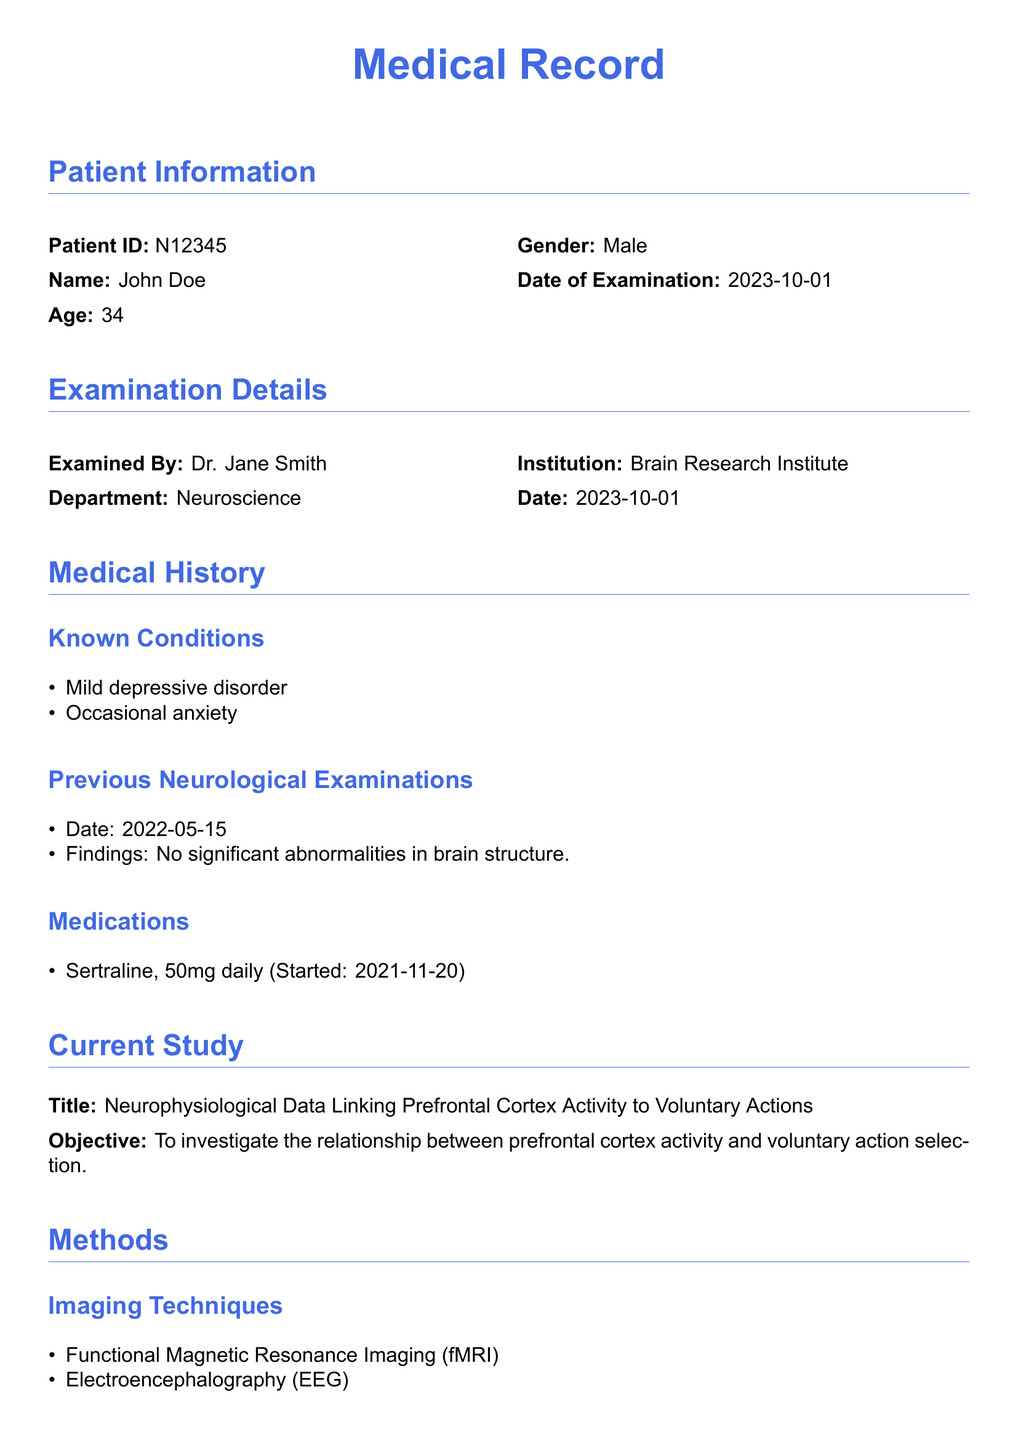What is the patient's age? The patient's age is directly mentioned in the document under Patient Information.
Answer: 34 Who examined the patient? The name of the person who examined the patient is listed in the Examination Details section.
Answer: Dr. Jane Smith What imaging techniques were used in the study? The document lists the imaging techniques used under the Methods section.
Answer: Functional Magnetic Resonance Imaging (fMRI), Electroencephalography (EEG) Which brain regions showed increased activity during voluntary action tasks? The document specifies the implicated brain regions under Prefrontal Cortex Activity in the Findings section.
Answer: Dorsolateral Prefrontal Cortex (DLPFC), Anterior Cingulate Cortex (ACC) What medication is the patient currently taking? The current medication of the patient is mentioned in the Medications subsection of the Medical History.
Answer: Sertraline, 50mg daily What is the study's objective? The objective of the study is stated in the Current Study section.
Answer: To investigate the relationship between prefrontal cortex activity and voluntary action selection Which condition is mentioned in the patient's medical history related to voluntary action impairment? The Medical History section lists conditions that could impair voluntary action.
Answer: Mild depressive disorder What conclusion does the study provide regarding free will? The conclusion summarizes the study's implications on the understanding of free will.
Answer: The data indicates a significant link between prefrontal cortex activity and voluntary action 